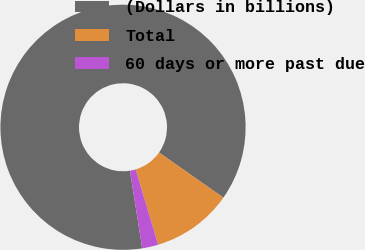Convert chart. <chart><loc_0><loc_0><loc_500><loc_500><pie_chart><fcel>(Dollars in billions)<fcel>Total<fcel>60 days or more past due<nl><fcel>87.24%<fcel>10.64%<fcel>2.12%<nl></chart> 